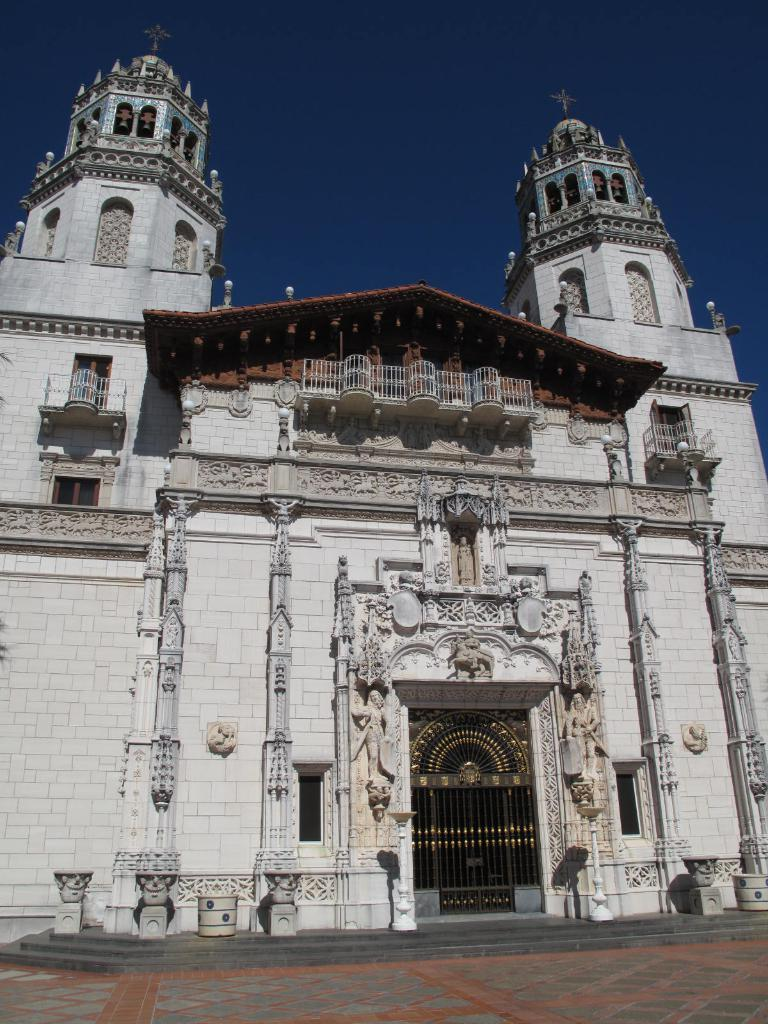What type of building is in the image? There is a church in the image. What decorative elements can be seen on the church? The church has sculptures on the walls. What architectural feature is present in the image? There is a gate in the image. What is visible at the top of the image? The sky is visible at the top of the image. What is visible at the bottom of the image? The floor is visible at the bottom of the image. How many hands are holding the tin in the image? There is no tin or hands present in the image. 